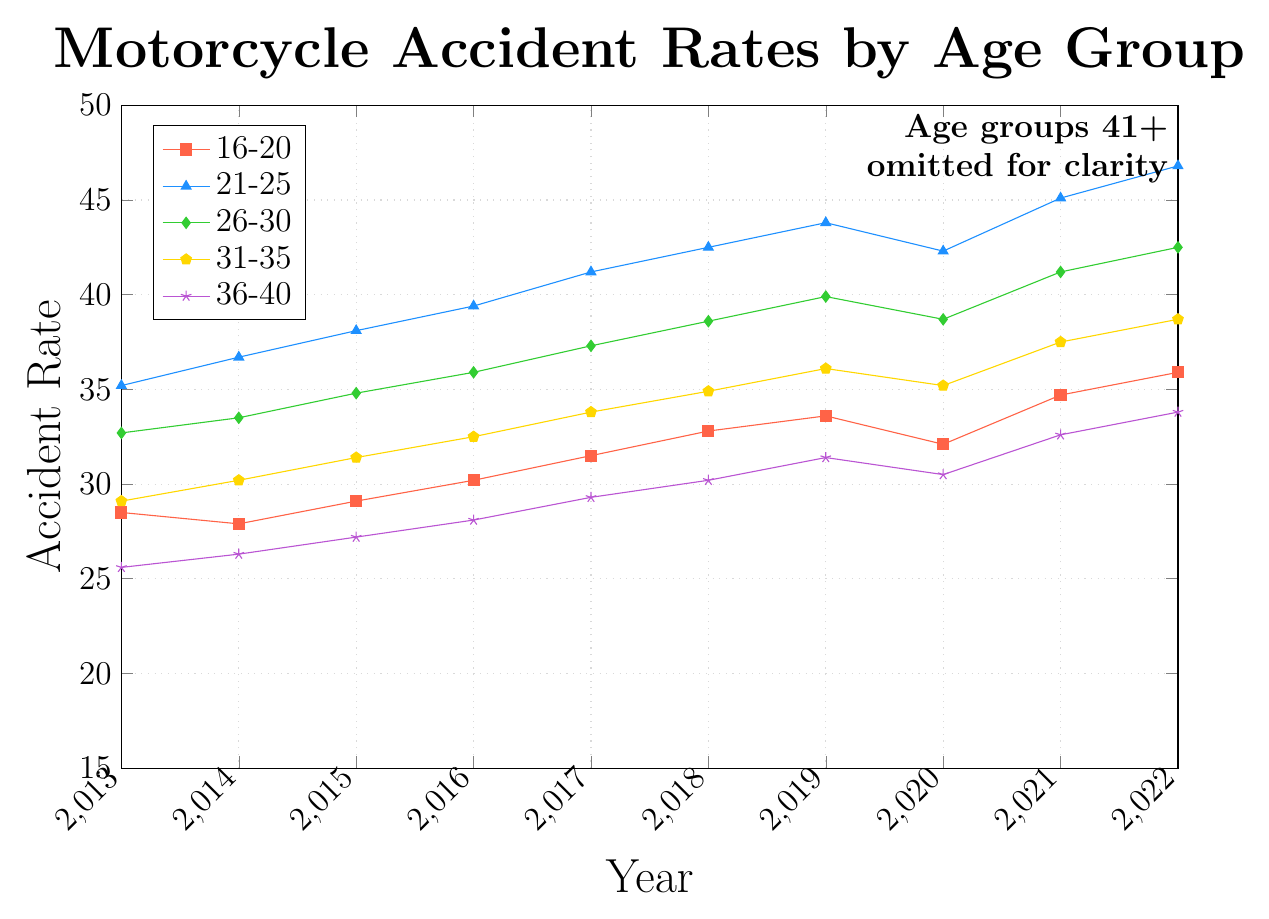What's the trend in accident rates for the age group 21-25 over the past decade? Observe the line representing the 21-25 age group in the figure, and note how the values change from 2013 to 2022. The trend shows an increase over the years.
Answer: Increasing Which age group has the highest accident rate in 2022? Identify the age group with the tallest point on the y-axis in 2022. The age group 21-25 has the highest accident rate at 46.8.
Answer: 21-25 Did the accident rate for the age group 16-20 increase, decrease, or remain stable between 2013 and 2020? Compare the values from 2013 and 2020 for the 16-20 age group. Accident rates increased from 28.5 in 2013 to 32.1 in 2020.
Answer: Increase What is the rate change for the age group 36-40 from 2013 to 2022? Subtract the 2013 value from the 2022 value for the 36-40 age group: 33.8 - 25.6 = 8.2.
Answer: 8.2 Which age group had the most consistent (least variable) accident rates over the decade? Look for the line that has the least fluctuation (smallest changes in height) across all years. The age group 61+ shows the least variability.
Answer: 61+ Compare the accident rates of the age groups 31-35 and 41-45 in 2017. Which is higher? Locate the points for 2017 for both age groups and compare their heights. The 31-35 age group has a higher rate (33.8) compared to 41-45 (25.7).
Answer: 31-35 What's the average accident rate for the age group 26-30 from 2019 to 2021? Add the values for 2019, 2020, and 2021, then divide by 3: (39.9 + 38.7 + 41.2) / 3 = 39.93.
Answer: 39.93 How did the accident rate for the age group 51-55 change from 2018 to 2020? Compare the values from 2018 and 2020 for the 51-55 age group: 21.4 in 2018 and 21.5 in 2020. The rate increased.
Answer: Increased Among the age groups 16-20, 21-25, and 26-30, which had the highest accident rate in 2016? Identify the points for 2016 for each of the age groups and compare their values. The age group 21-25 had the highest rate at 39.4.
Answer: 21-25 What's the difference in accident rates between the age groups 41-45 and 61+ in 2022? Subtract the 2022 value for the 61+ group from the 41-45 group: 29.5 - 19.4 = 10.1.
Answer: 10.1 